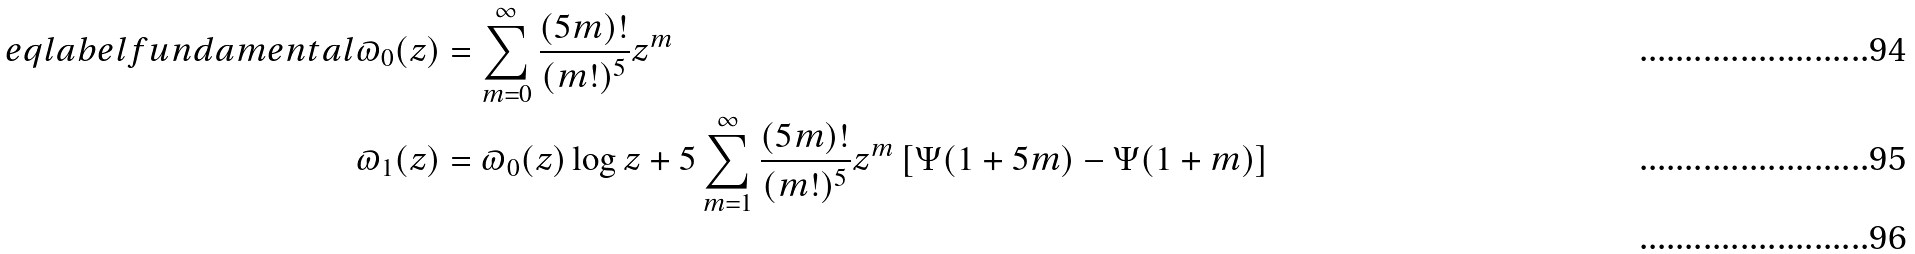Convert formula to latex. <formula><loc_0><loc_0><loc_500><loc_500>\ e q l a b e l { f u n d a m e n t a l } \varpi _ { 0 } ( z ) & = \sum _ { m = 0 } ^ { \infty } \frac { ( 5 m ) ! } { ( m ! ) ^ { 5 } } z ^ { m } \\ \varpi _ { 1 } ( z ) & = \varpi _ { 0 } ( z ) \log z + 5 \sum _ { m = 1 } ^ { \infty } \frac { ( 5 m ) ! } { ( m ! ) ^ { 5 } } z ^ { m } \left [ \Psi ( 1 + 5 m ) - \Psi ( 1 + m ) \right ] \\</formula> 